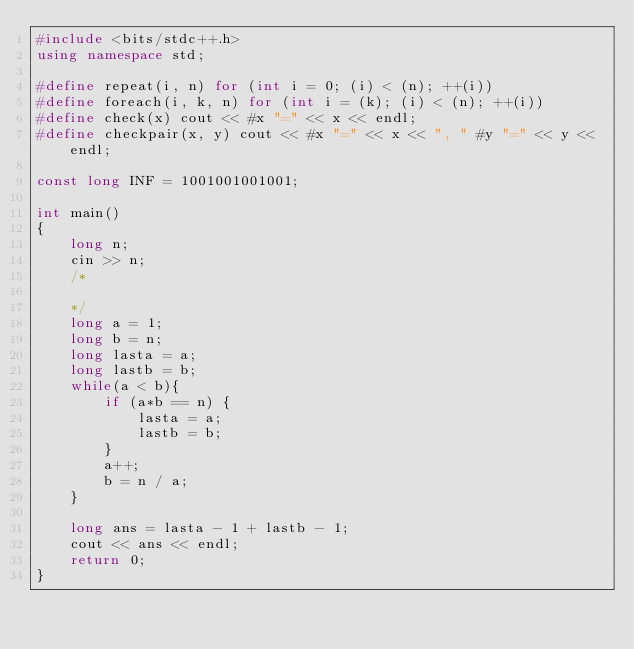<code> <loc_0><loc_0><loc_500><loc_500><_C++_>#include <bits/stdc++.h>
using namespace std;

#define repeat(i, n) for (int i = 0; (i) < (n); ++(i))
#define foreach(i, k, n) for (int i = (k); (i) < (n); ++(i))
#define check(x) cout << #x "=" << x << endl;
#define checkpair(x, y) cout << #x "=" << x << ", " #y "=" << y << endl;

const long INF = 1001001001001;

int main()
{
    long n;
    cin >> n;
    /*

    */
    long a = 1;
    long b = n;
    long lasta = a;
    long lastb = b;
    while(a < b){
        if (a*b == n) {
            lasta = a;
            lastb = b;
        }
        a++;
        b = n / a;
    }

    long ans = lasta - 1 + lastb - 1;
    cout << ans << endl;
    return 0;
}
</code> 